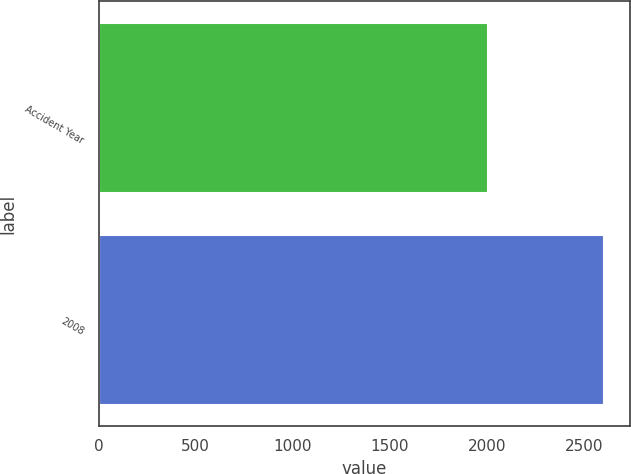Convert chart to OTSL. <chart><loc_0><loc_0><loc_500><loc_500><bar_chart><fcel>Accident Year<fcel>2008<nl><fcel>2009<fcel>2607<nl></chart> 